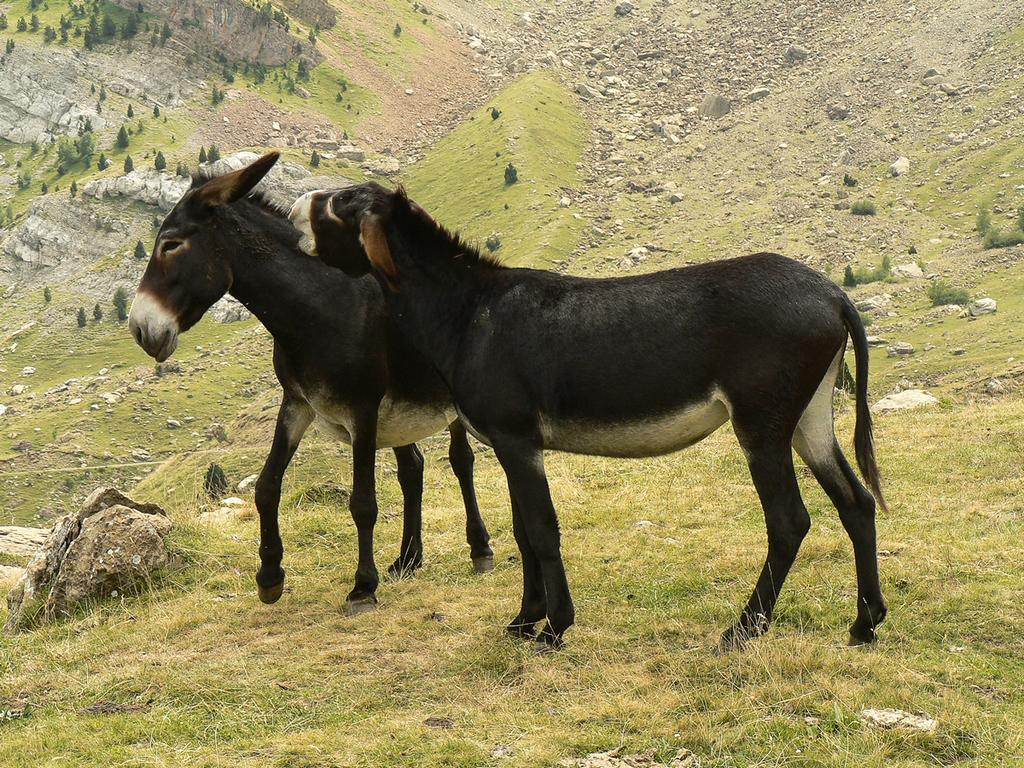How many donkeys are in the image? There are two donkeys in the image. What is the terrain where the donkeys are standing? The donkeys are standing on grassland. What can be seen in the background of the image? Hills are visible in the background of the image. What type of vegetation is present on the hills? Trees are present on the hills. What else can be found on the hills? Stones are scattered on the hills. What type of zephyr is blowing through the image? There is no mention of a zephyr in the image, so it cannot be determined what type might be present. 